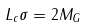Convert formula to latex. <formula><loc_0><loc_0><loc_500><loc_500>L _ { c } \sigma = 2 M _ { G }</formula> 